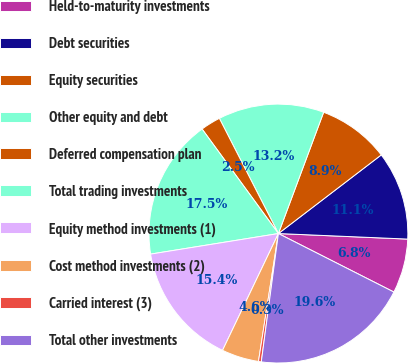Convert chart. <chart><loc_0><loc_0><loc_500><loc_500><pie_chart><fcel>Held-to-maturity investments<fcel>Debt securities<fcel>Equity securities<fcel>Other equity and debt<fcel>Deferred compensation plan<fcel>Total trading investments<fcel>Equity method investments (1)<fcel>Cost method investments (2)<fcel>Carried interest (3)<fcel>Total other investments<nl><fcel>6.78%<fcel>11.07%<fcel>8.93%<fcel>13.22%<fcel>2.5%<fcel>17.5%<fcel>15.36%<fcel>4.64%<fcel>0.35%<fcel>19.65%<nl></chart> 